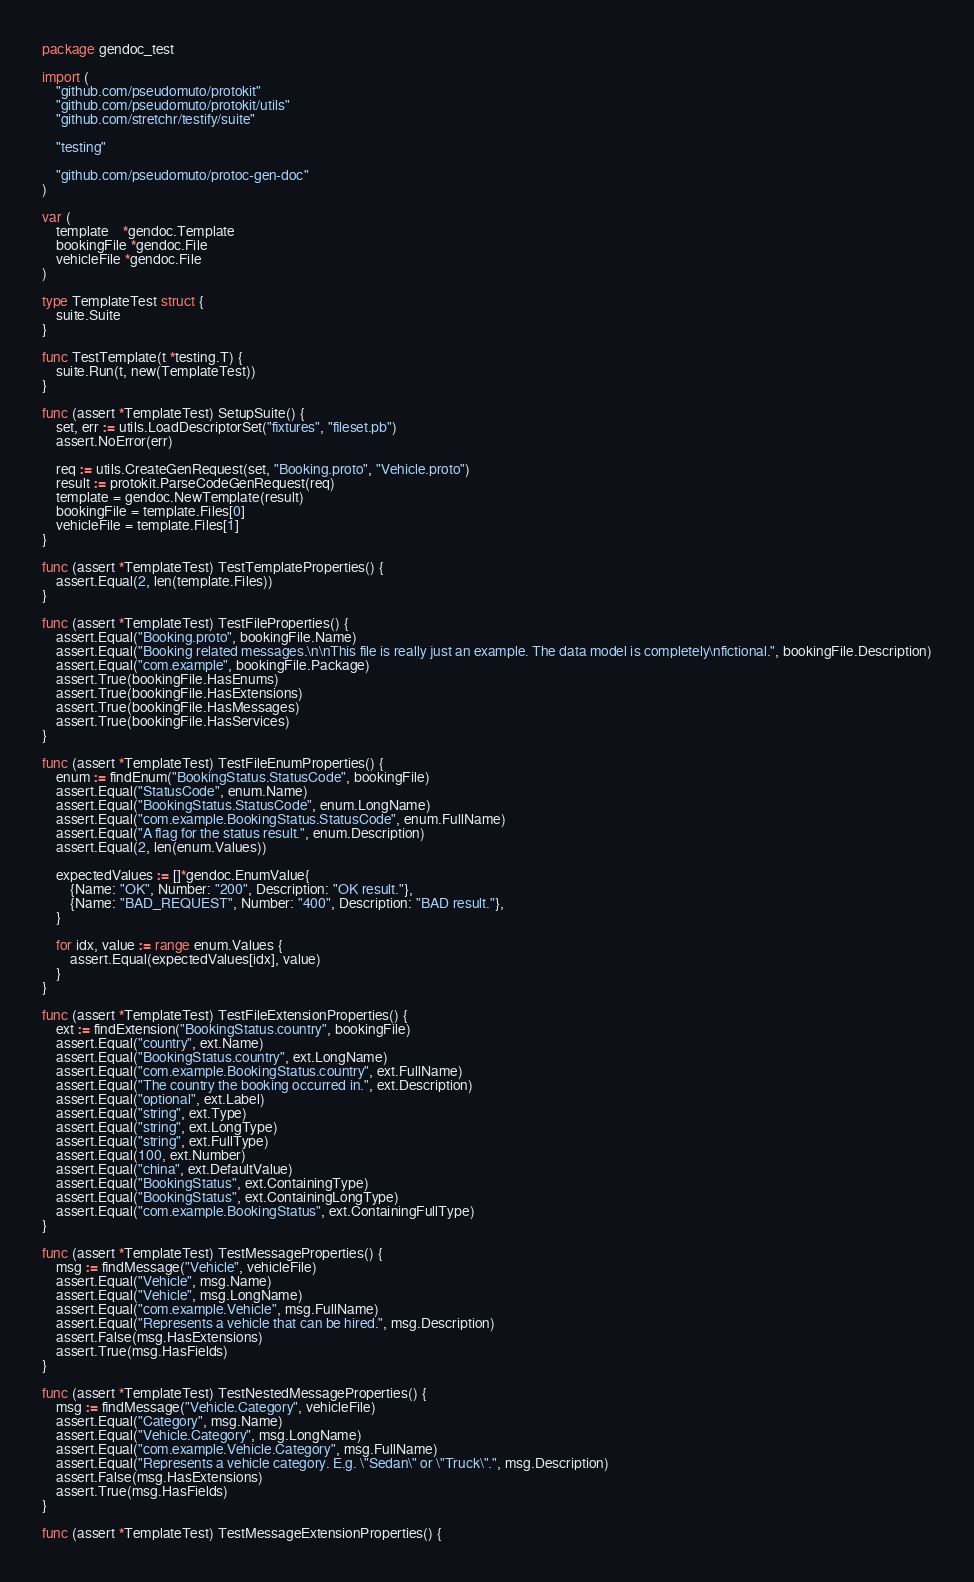<code> <loc_0><loc_0><loc_500><loc_500><_Go_>package gendoc_test

import (
	"github.com/pseudomuto/protokit"
	"github.com/pseudomuto/protokit/utils"
	"github.com/stretchr/testify/suite"

	"testing"

	"github.com/pseudomuto/protoc-gen-doc"
)

var (
	template    *gendoc.Template
	bookingFile *gendoc.File
	vehicleFile *gendoc.File
)

type TemplateTest struct {
	suite.Suite
}

func TestTemplate(t *testing.T) {
	suite.Run(t, new(TemplateTest))
}

func (assert *TemplateTest) SetupSuite() {
	set, err := utils.LoadDescriptorSet("fixtures", "fileset.pb")
	assert.NoError(err)

	req := utils.CreateGenRequest(set, "Booking.proto", "Vehicle.proto")
	result := protokit.ParseCodeGenRequest(req)
	template = gendoc.NewTemplate(result)
	bookingFile = template.Files[0]
	vehicleFile = template.Files[1]
}

func (assert *TemplateTest) TestTemplateProperties() {
	assert.Equal(2, len(template.Files))
}

func (assert *TemplateTest) TestFileProperties() {
	assert.Equal("Booking.proto", bookingFile.Name)
	assert.Equal("Booking related messages.\n\nThis file is really just an example. The data model is completely\nfictional.", bookingFile.Description)
	assert.Equal("com.example", bookingFile.Package)
	assert.True(bookingFile.HasEnums)
	assert.True(bookingFile.HasExtensions)
	assert.True(bookingFile.HasMessages)
	assert.True(bookingFile.HasServices)
}

func (assert *TemplateTest) TestFileEnumProperties() {
	enum := findEnum("BookingStatus.StatusCode", bookingFile)
	assert.Equal("StatusCode", enum.Name)
	assert.Equal("BookingStatus.StatusCode", enum.LongName)
	assert.Equal("com.example.BookingStatus.StatusCode", enum.FullName)
	assert.Equal("A flag for the status result.", enum.Description)
	assert.Equal(2, len(enum.Values))

	expectedValues := []*gendoc.EnumValue{
		{Name: "OK", Number: "200", Description: "OK result."},
		{Name: "BAD_REQUEST", Number: "400", Description: "BAD result."},
	}

	for idx, value := range enum.Values {
		assert.Equal(expectedValues[idx], value)
	}
}

func (assert *TemplateTest) TestFileExtensionProperties() {
	ext := findExtension("BookingStatus.country", bookingFile)
	assert.Equal("country", ext.Name)
	assert.Equal("BookingStatus.country", ext.LongName)
	assert.Equal("com.example.BookingStatus.country", ext.FullName)
	assert.Equal("The country the booking occurred in.", ext.Description)
	assert.Equal("optional", ext.Label)
	assert.Equal("string", ext.Type)
	assert.Equal("string", ext.LongType)
	assert.Equal("string", ext.FullType)
	assert.Equal(100, ext.Number)
	assert.Equal("china", ext.DefaultValue)
	assert.Equal("BookingStatus", ext.ContainingType)
	assert.Equal("BookingStatus", ext.ContainingLongType)
	assert.Equal("com.example.BookingStatus", ext.ContainingFullType)
}

func (assert *TemplateTest) TestMessageProperties() {
	msg := findMessage("Vehicle", vehicleFile)
	assert.Equal("Vehicle", msg.Name)
	assert.Equal("Vehicle", msg.LongName)
	assert.Equal("com.example.Vehicle", msg.FullName)
	assert.Equal("Represents a vehicle that can be hired.", msg.Description)
	assert.False(msg.HasExtensions)
	assert.True(msg.HasFields)
}

func (assert *TemplateTest) TestNestedMessageProperties() {
	msg := findMessage("Vehicle.Category", vehicleFile)
	assert.Equal("Category", msg.Name)
	assert.Equal("Vehicle.Category", msg.LongName)
	assert.Equal("com.example.Vehicle.Category", msg.FullName)
	assert.Equal("Represents a vehicle category. E.g. \"Sedan\" or \"Truck\".", msg.Description)
	assert.False(msg.HasExtensions)
	assert.True(msg.HasFields)
}

func (assert *TemplateTest) TestMessageExtensionProperties() {</code> 